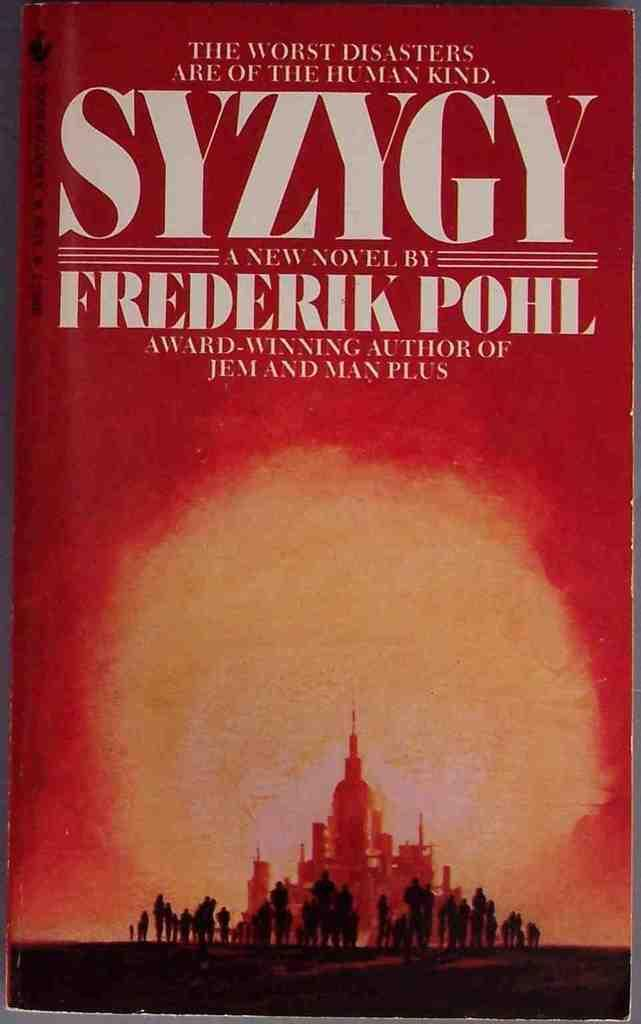What is the main object in the image? There is a book in the image. What type of content is present in the book? The book contains pictures and text. What type of rod is used to hold the umbrella in the image? There is no rod or umbrella present in the image; it only features a book with pictures and text. 